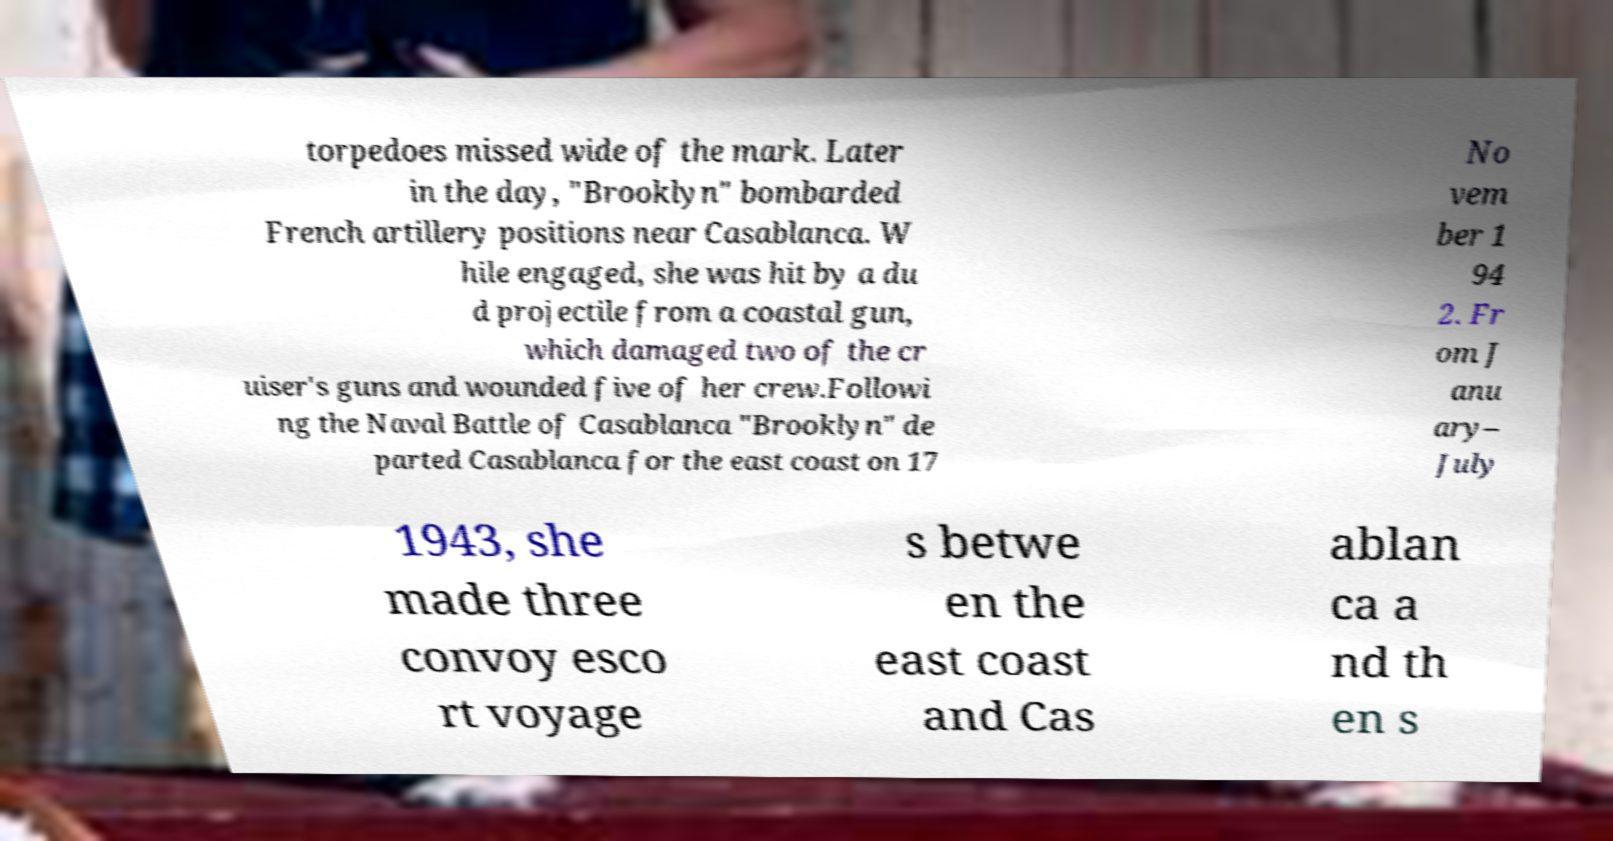Can you accurately transcribe the text from the provided image for me? torpedoes missed wide of the mark. Later in the day, "Brooklyn" bombarded French artillery positions near Casablanca. W hile engaged, she was hit by a du d projectile from a coastal gun, which damaged two of the cr uiser's guns and wounded five of her crew.Followi ng the Naval Battle of Casablanca "Brooklyn" de parted Casablanca for the east coast on 17 No vem ber 1 94 2. Fr om J anu ary– July 1943, she made three convoy esco rt voyage s betwe en the east coast and Cas ablan ca a nd th en s 